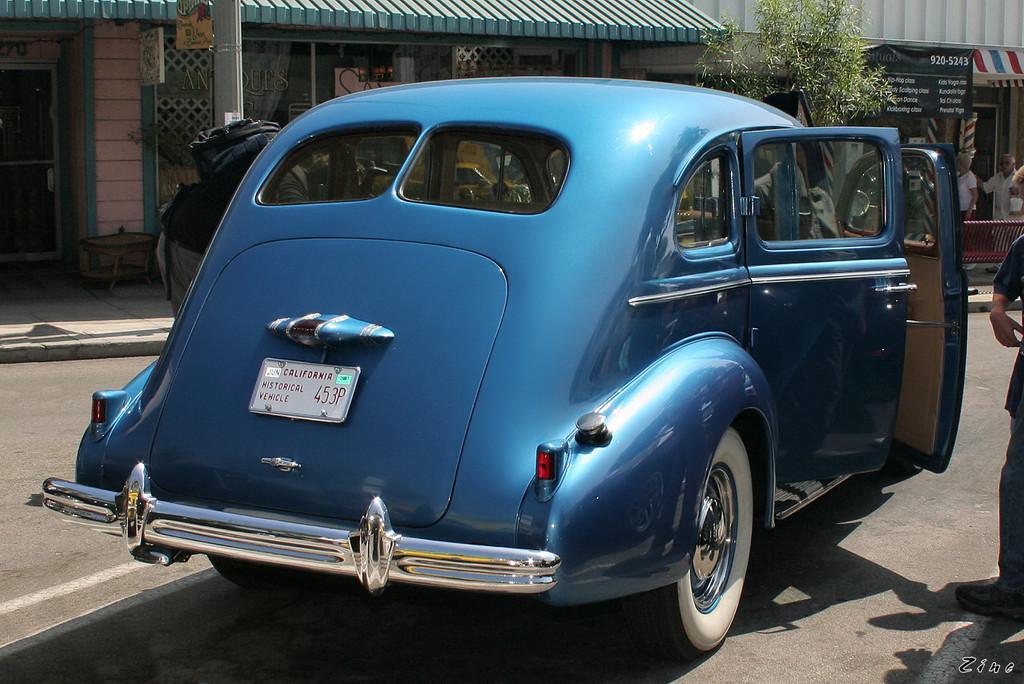Describe this image in one or two sentences. In this image we can see few stores. There is a car on the road in the image. There is a plant in the image. There are many people in the image. 